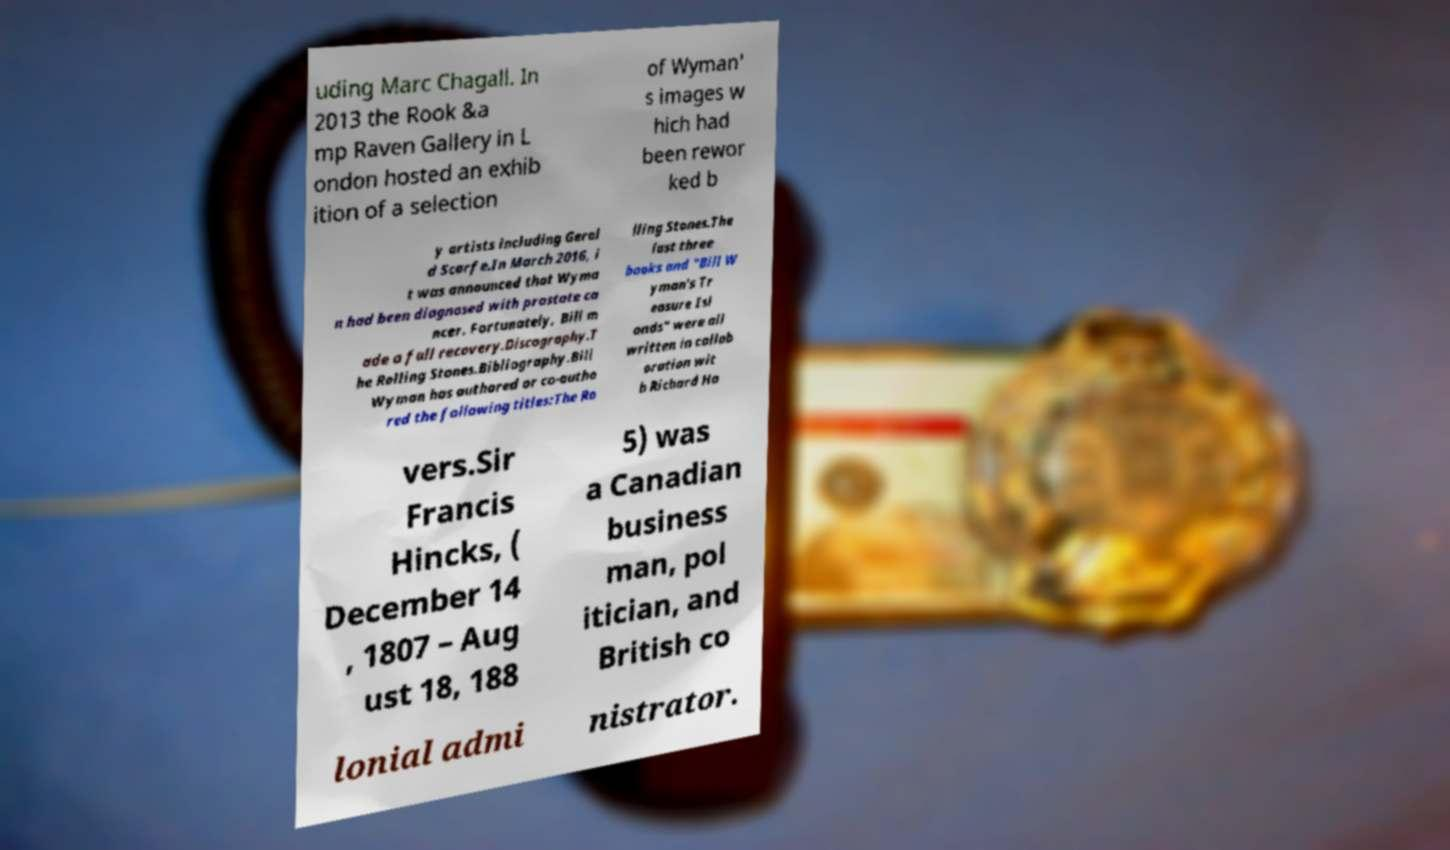Could you extract and type out the text from this image? uding Marc Chagall. In 2013 the Rook &a mp Raven Gallery in L ondon hosted an exhib ition of a selection of Wyman' s images w hich had been rewor ked b y artists including Geral d Scarfe.In March 2016, i t was announced that Wyma n had been diagnosed with prostate ca ncer. Fortunately, Bill m ade a full recovery.Discography.T he Rolling Stones.Bibliography.Bill Wyman has authored or co-autho red the following titles:The Ro lling Stones.The last three books and "Bill W yman's Tr easure Isl ands" were all written in collab oration wit h Richard Ha vers.Sir Francis Hincks, ( December 14 , 1807 – Aug ust 18, 188 5) was a Canadian business man, pol itician, and British co lonial admi nistrator. 